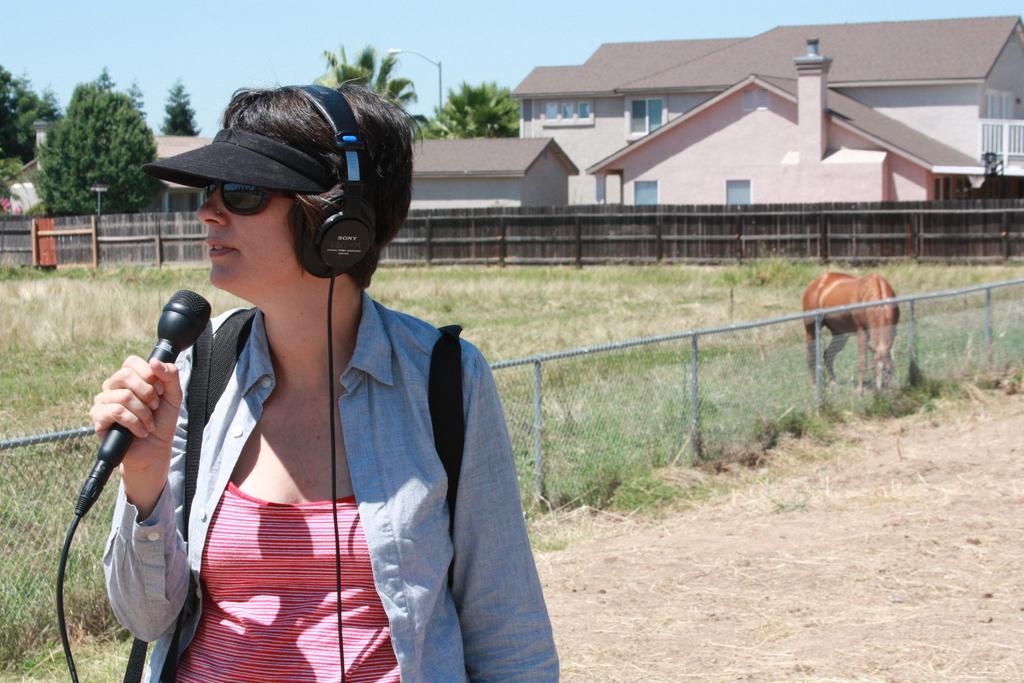Describe this image in one or two sentences. In this picture its a sunny day , where a woman with headphones and mic in her hand. Behind her there is a grassland and a horse located in it. In the background we observe a beautiful house which has windows and also tress surmounted around it. 